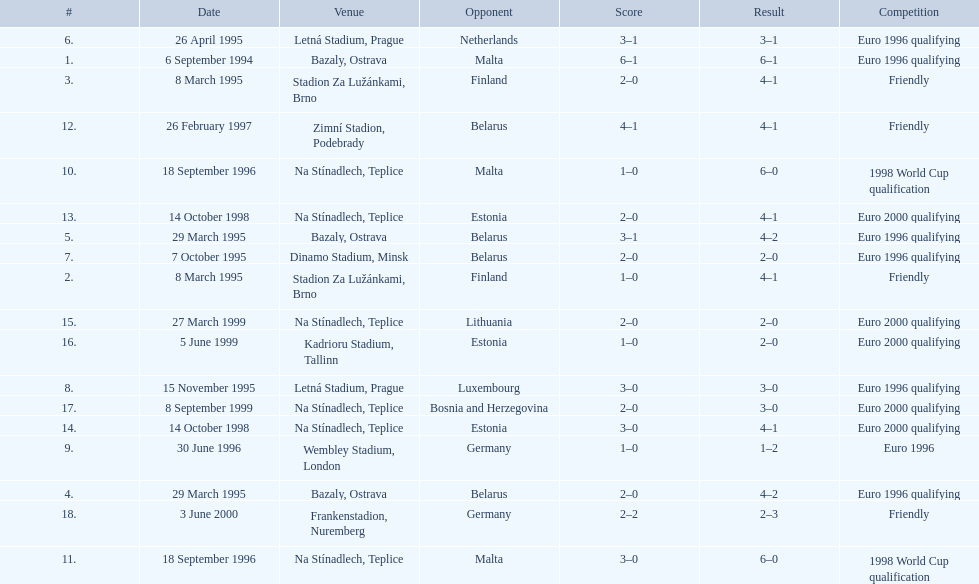Bazaly, ostrava was used on 6 september 1004, but what venue was used on 18 september 1996? Na Stínadlech, Teplice. 